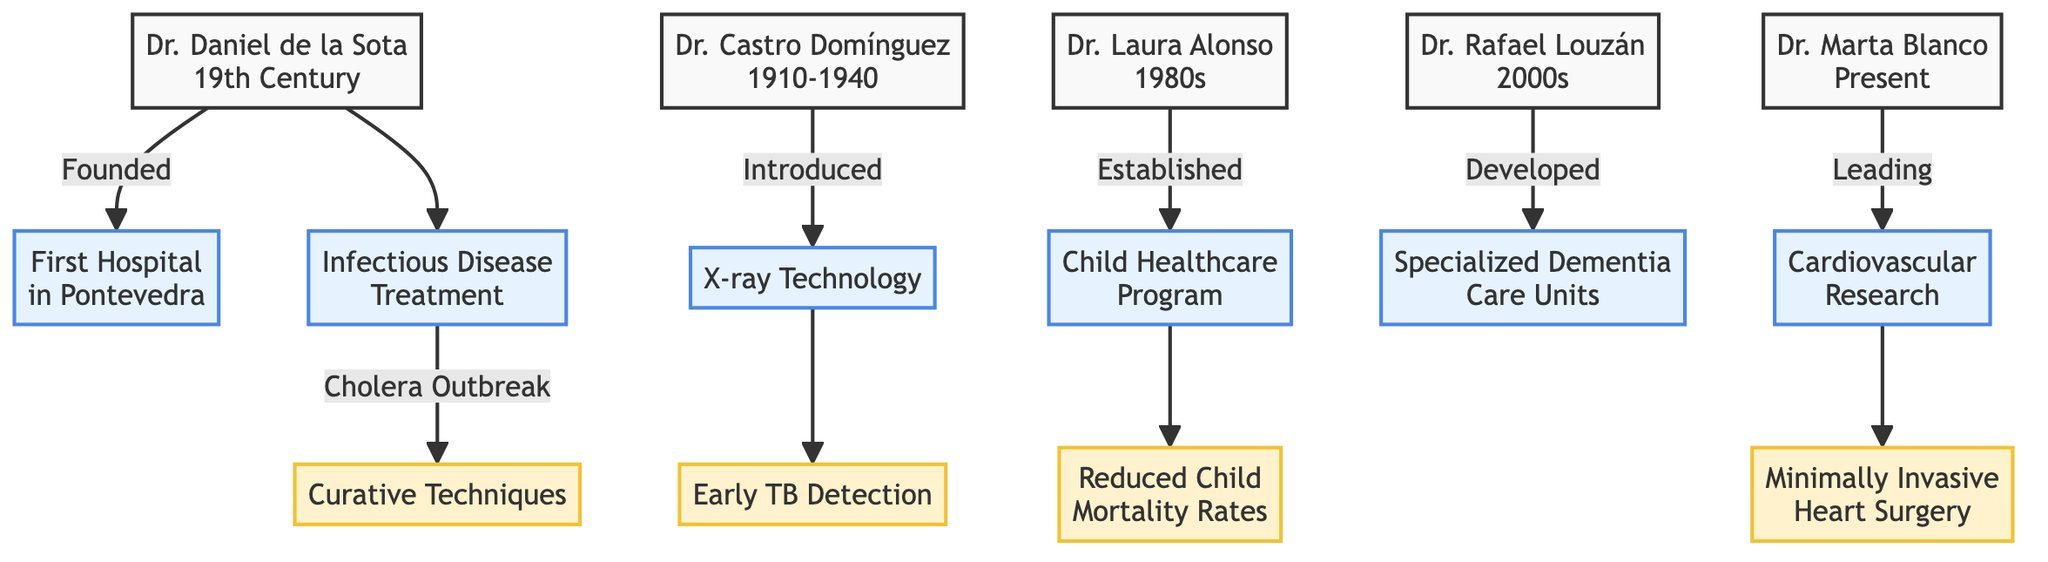What period did Dr. Daniel de la Sota work in? The diagram indicates that Dr. Daniel de la Sota worked in the 19th Century, as noted on his node.
Answer: 19th Century How many key medical figures are represented in the diagram? By counting the nodes representing the key medical figures, there are a total of five figures: Dr. Daniel de la Sota, Dr. Castro Domínguez, Dr. Laura Alonso, Dr. Rafael Louzán, and Dr. Marta Blanco.
Answer: 5 What notable work is associated with Dr. Castro Domínguez? The notable work listed under Dr. Castro Domínguez's node is the "Early detection of tuberculosis through X-ray imaging."
Answer: Early detection of tuberculosis through X-ray imaging Which medical figure is linked to advancements in geriatric care? Dr. Rafael Louzán is identified in the diagram as having contributions specifically related to advancements in geriatric care, as stated in his node.
Answer: Dr. Rafael Louzán What medical technology did Dr. Castro Domínguez introduce? The diagram clearly states that Dr. Castro Domínguez introduced X-ray technology to local hospitals, as highlighted in the connections from his node.
Answer: X-ray technology Who established the Child Healthcare Program? The node for Dr. Laura Alonso indicates that she is the medical figure who established the Child Healthcare Program, as mentioned in her contributions.
Answer: Dr. Laura Alonso What was a significant contribution of Dr. Daniel de la Sota? According to the diagram, a significant contribution of Dr. Daniel de la Sota was advancements in infectious disease treatment, which is noted in his contributions.
Answer: Advancements in infectious disease treatment How does Dr. Marta Blanco contribute to medical research? The diagram indicates that Dr. Marta Blanco leads research in cardiovascular diseases, detailing her contributions to advancements in modern cardiovascular surgical techniques.
Answer: Leading research in cardiovascular diseases What is the focus of Dr. Laura Alonso's notable work? The notable work for Dr. Laura Alonso mentioned in the diagram is about reducing child mortality rates in urban and rural areas, which highlights her focus on improving child health outcomes.
Answer: Reducing child mortality rates in urban and rural areas 